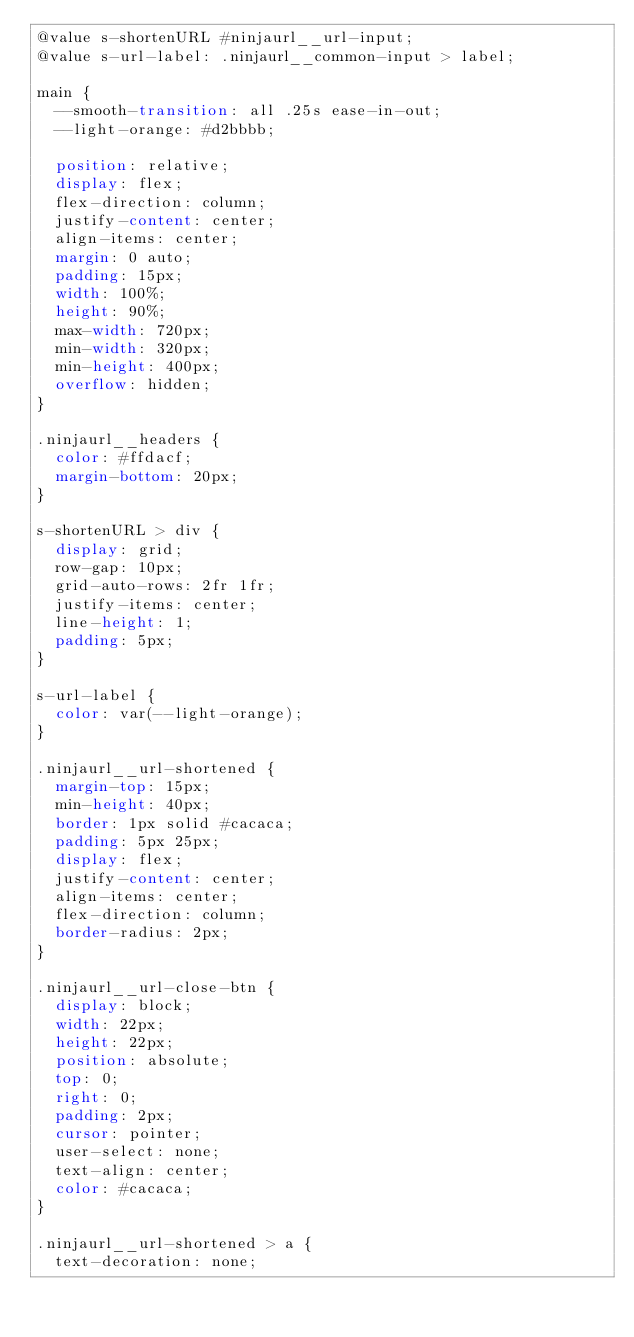<code> <loc_0><loc_0><loc_500><loc_500><_CSS_>@value s-shortenURL #ninjaurl__url-input;
@value s-url-label: .ninjaurl__common-input > label;

main {
  --smooth-transition: all .25s ease-in-out;
  --light-orange: #d2bbbb;

  position: relative;
  display: flex;
  flex-direction: column;
  justify-content: center;
  align-items: center;
  margin: 0 auto;
  padding: 15px;
  width: 100%;
  height: 90%;
  max-width: 720px;
  min-width: 320px;
  min-height: 400px;
  overflow: hidden;
}

.ninjaurl__headers {
  color: #ffdacf;
  margin-bottom: 20px;
}

s-shortenURL > div {
  display: grid;
  row-gap: 10px;
  grid-auto-rows: 2fr 1fr;
  justify-items: center;
  line-height: 1;
  padding: 5px;
}

s-url-label {
  color: var(--light-orange);
}

.ninjaurl__url-shortened {
  margin-top: 15px;
  min-height: 40px;
  border: 1px solid #cacaca;
  padding: 5px 25px;
  display: flex;
  justify-content: center;
  align-items: center;
  flex-direction: column;
  border-radius: 2px;
}

.ninjaurl__url-close-btn {
  display: block;
  width: 22px;
  height: 22px;
  position: absolute;
  top: 0;
  right: 0;
  padding: 2px;
  cursor: pointer;
  user-select: none;
  text-align: center;
  color: #cacaca;
}

.ninjaurl__url-shortened > a {
  text-decoration: none;</code> 